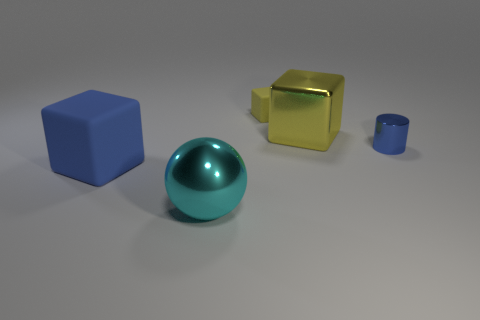How would you describe the lighting in this scene? The lighting in the scene appears to be soft and diffused, with gentle shadows indicating the light source may be relatively large and not too far from the objects. 